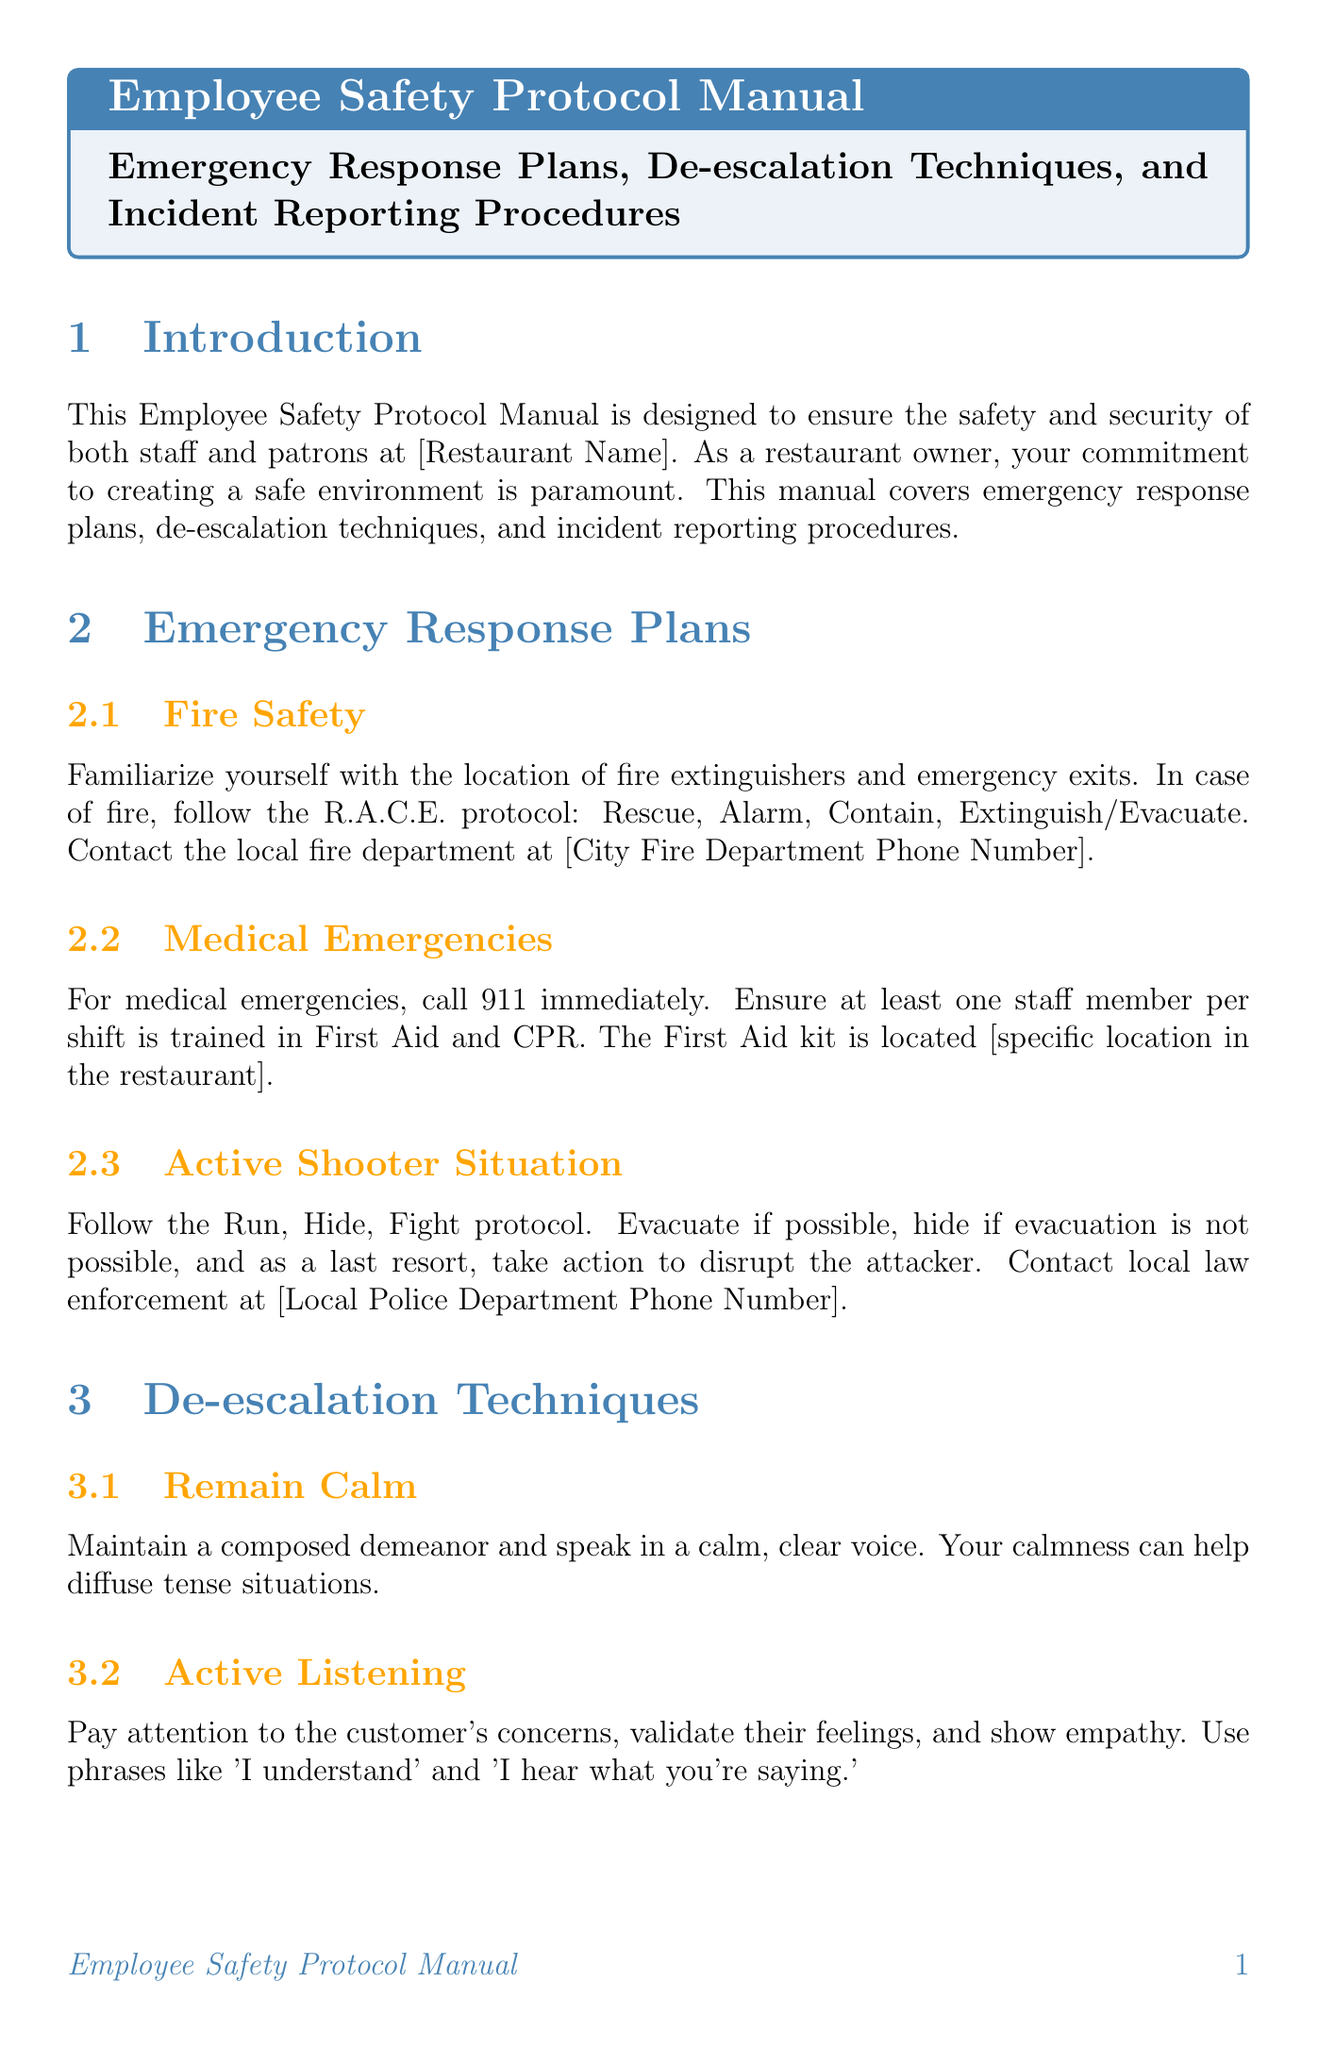What is the primary purpose of the manual? The manual is designed to ensure the safety and security of both staff and patrons at the restaurant.
Answer: safety and security Which emergency number should be called for medical emergencies? The manual states to call 911 immediately for medical emergencies.
Answer: 911 What does the acronym R.A.C.E. stand for in fire safety? R.A.C.E. stands for Rescue, Alarm, Contain, Extinguish/Evacuate.
Answer: Rescue, Alarm, Contain, Extinguish/Evacuate What should be done if a situation becomes threatening? The protocol advises to remove yourself and contact security or law enforcement.
Answer: contact security or law enforcement Who will review incident reports within 24 hours? The management is responsible for reviewing all incident reports within 24 hours.
Answer: Management What type of incidents should be reported according to the document? The document specifies accidents, injuries, thefts, threats, and altercations must be reported.
Answer: accidents, injuries, thefts, threats, altercations What is the first step in the emergency response plan for medical emergencies? The first step is to call 911 immediately.
Answer: call 911 Who must complete safety training? All employees must complete safety training upon hiring and annually thereafter.
Answer: All employees What is the main technique suggested to de-escalate tense situations? The manual suggests remaining calm as a primary technique to de-escalate tensions.
Answer: remain calm 